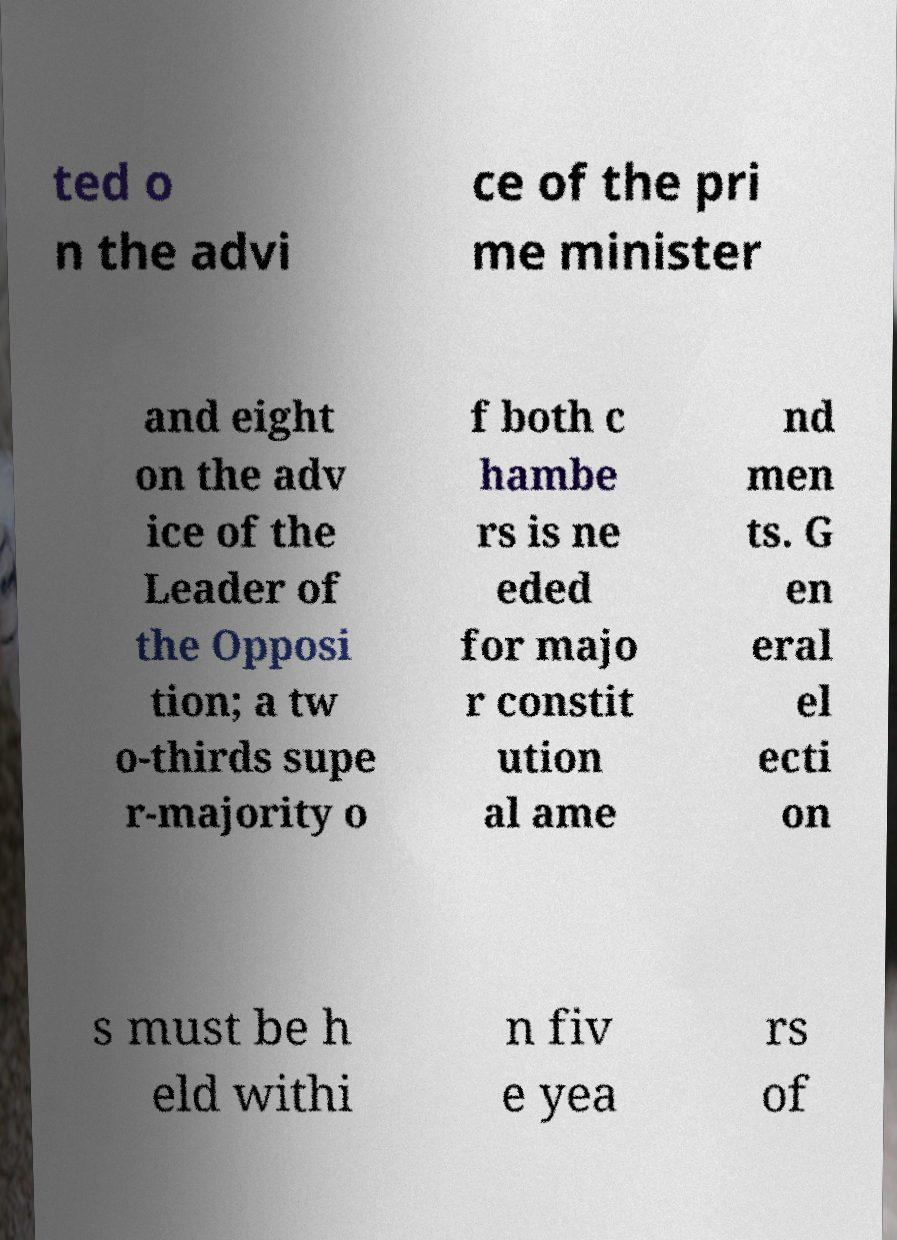There's text embedded in this image that I need extracted. Can you transcribe it verbatim? The text in this image appears to be out of order and partially obscured. It seems to discuss a political process, possibly the appointment of officials and constitutional amendments that require a super-majority. Elections are mentioned as needing to occur within five years. However, without the ability to view the entire context or reorder the text, a precise and complete transcription isn't feasible. 